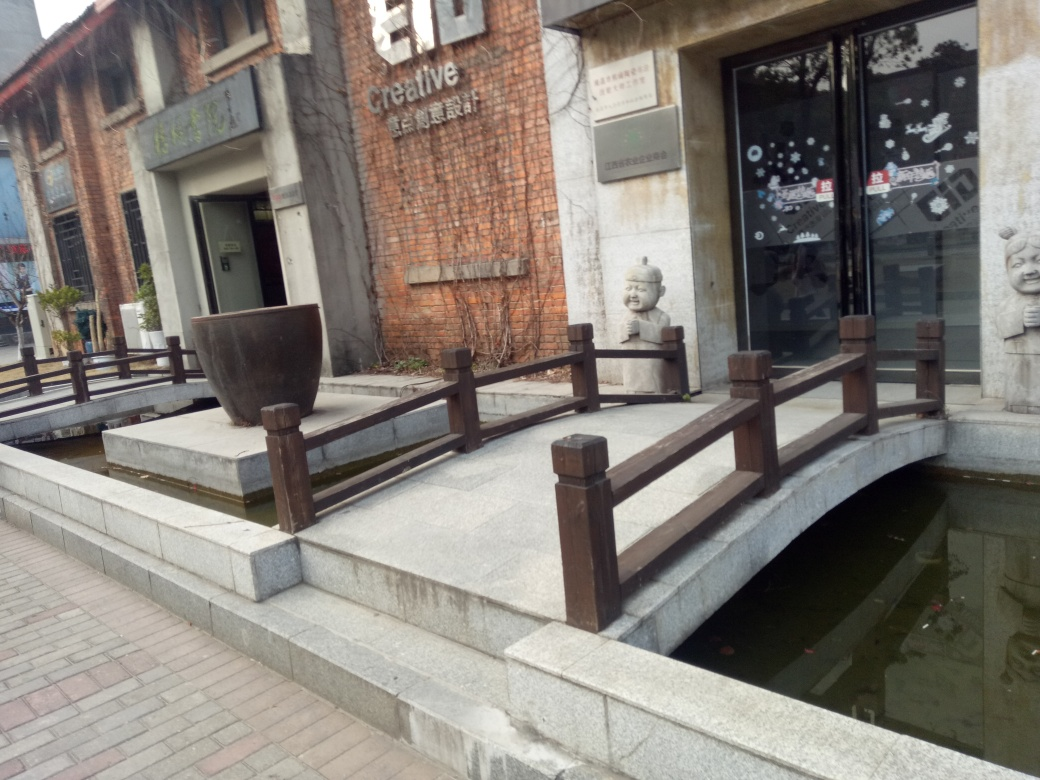What can we infer about the location from the image? The image hints at an urban location with a focus on artistic or cultural activities. The brick wall of the building and the sculptures are characteristic of a place that has been repurposed for creative pursuits, perhaps an old industrial area that has been transformed into a cultural hub. The serene water feature adds a tranquil aspect to the environment. This location could be part of a larger district that encourages pedestrian movement and features art prominently in the urban landscape. 